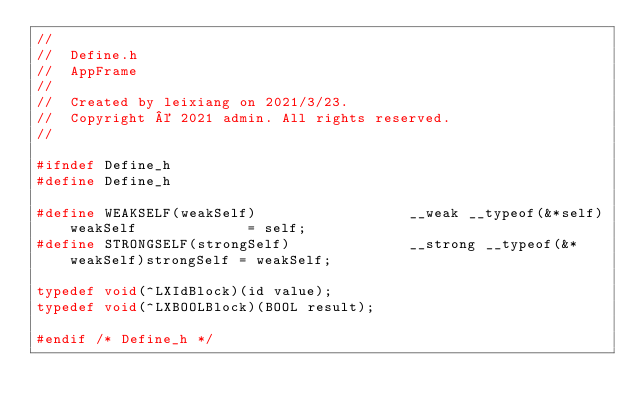<code> <loc_0><loc_0><loc_500><loc_500><_C_>//
//  Define.h
//  AppFrame
//
//  Created by leixiang on 2021/3/23.
//  Copyright © 2021 admin. All rights reserved.
//

#ifndef Define_h
#define Define_h

#define WEAKSELF(weakSelf)                  __weak __typeof(&*self)weakSelf             = self;
#define STRONGSELF(strongSelf)              __strong __typeof(&*weakSelf)strongSelf = weakSelf;

typedef void(^LXIdBlock)(id value);
typedef void(^LXBOOLBlock)(BOOL result);

#endif /* Define_h */
</code> 